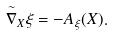<formula> <loc_0><loc_0><loc_500><loc_500>\overset { \sim } { \nabla } _ { X } \xi = - A _ { \xi } ( X ) .</formula> 